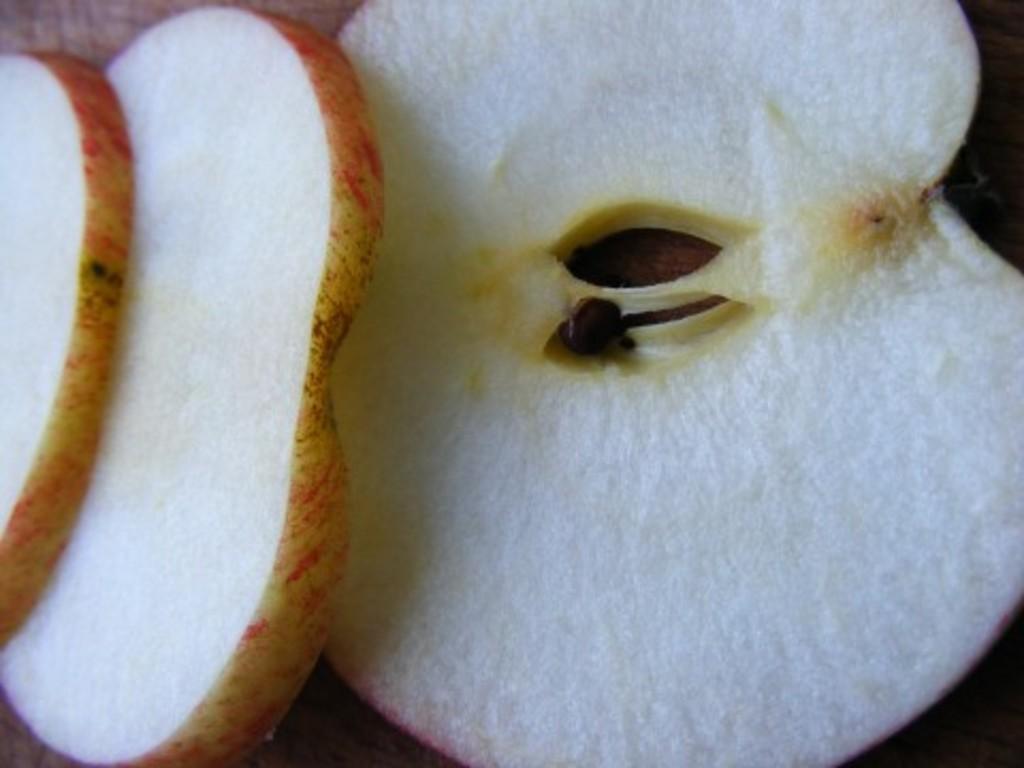Describe this image in one or two sentences. In this picture we can observe slices of apple. There are in white and red color. We can observe a brown color seed. 